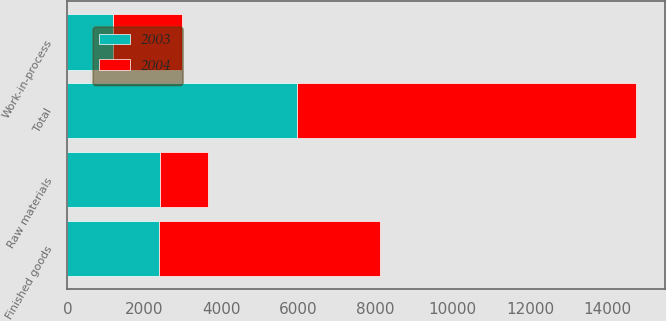Convert chart. <chart><loc_0><loc_0><loc_500><loc_500><stacked_bar_chart><ecel><fcel>Raw materials<fcel>Work-in-process<fcel>Finished goods<fcel>Total<nl><fcel>2003<fcel>2404<fcel>1183<fcel>2379<fcel>5966<nl><fcel>2004<fcel>1247<fcel>1797<fcel>5744<fcel>8788<nl></chart> 